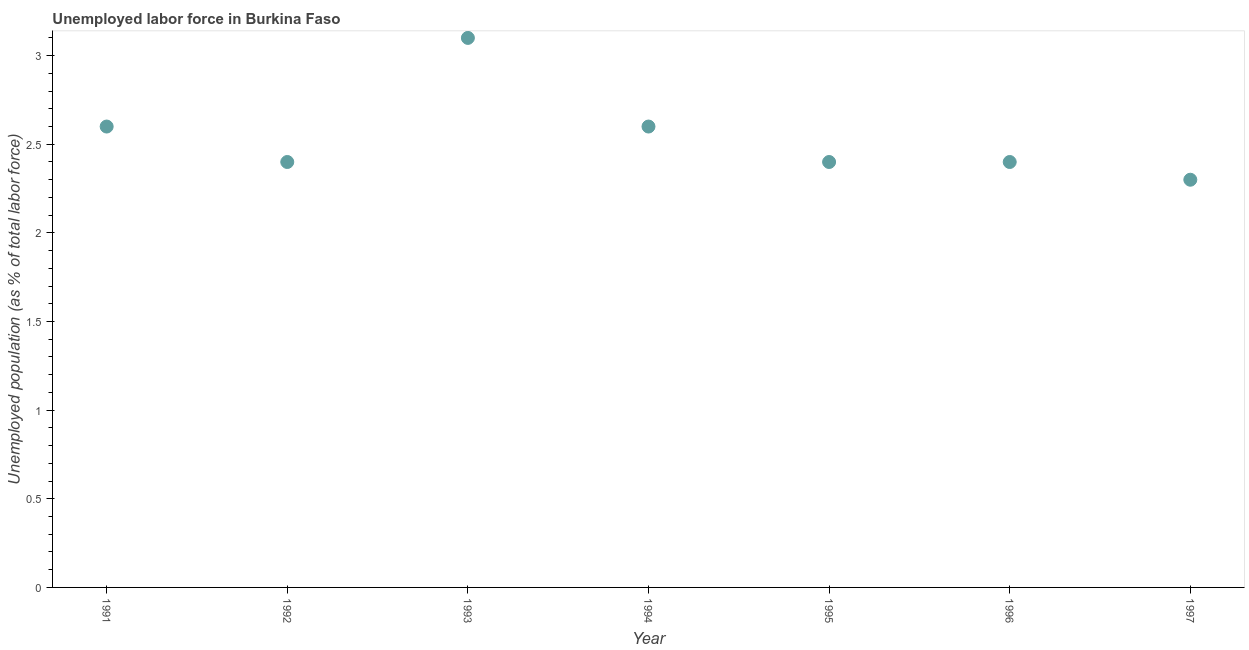What is the total unemployed population in 1991?
Give a very brief answer. 2.6. Across all years, what is the maximum total unemployed population?
Your response must be concise. 3.1. Across all years, what is the minimum total unemployed population?
Offer a terse response. 2.3. What is the sum of the total unemployed population?
Make the answer very short. 17.8. What is the difference between the total unemployed population in 1993 and 1997?
Provide a succinct answer. 0.8. What is the average total unemployed population per year?
Offer a very short reply. 2.54. What is the median total unemployed population?
Offer a very short reply. 2.4. In how many years, is the total unemployed population greater than 1.6 %?
Provide a succinct answer. 7. What is the ratio of the total unemployed population in 1993 to that in 1995?
Provide a short and direct response. 1.29. Is the total unemployed population in 1991 less than that in 1995?
Ensure brevity in your answer.  No. What is the difference between the highest and the second highest total unemployed population?
Give a very brief answer. 0.5. Is the sum of the total unemployed population in 1991 and 1994 greater than the maximum total unemployed population across all years?
Give a very brief answer. Yes. What is the difference between the highest and the lowest total unemployed population?
Your answer should be compact. 0.8. Does the total unemployed population monotonically increase over the years?
Make the answer very short. No. How many dotlines are there?
Provide a succinct answer. 1. Are the values on the major ticks of Y-axis written in scientific E-notation?
Provide a succinct answer. No. Does the graph contain grids?
Your answer should be very brief. No. What is the title of the graph?
Make the answer very short. Unemployed labor force in Burkina Faso. What is the label or title of the X-axis?
Offer a very short reply. Year. What is the label or title of the Y-axis?
Make the answer very short. Unemployed population (as % of total labor force). What is the Unemployed population (as % of total labor force) in 1991?
Keep it short and to the point. 2.6. What is the Unemployed population (as % of total labor force) in 1992?
Keep it short and to the point. 2.4. What is the Unemployed population (as % of total labor force) in 1993?
Ensure brevity in your answer.  3.1. What is the Unemployed population (as % of total labor force) in 1994?
Offer a terse response. 2.6. What is the Unemployed population (as % of total labor force) in 1995?
Your response must be concise. 2.4. What is the Unemployed population (as % of total labor force) in 1996?
Ensure brevity in your answer.  2.4. What is the Unemployed population (as % of total labor force) in 1997?
Your answer should be compact. 2.3. What is the difference between the Unemployed population (as % of total labor force) in 1991 and 1992?
Provide a succinct answer. 0.2. What is the difference between the Unemployed population (as % of total labor force) in 1991 and 1993?
Your answer should be very brief. -0.5. What is the difference between the Unemployed population (as % of total labor force) in 1991 and 1994?
Offer a terse response. 0. What is the difference between the Unemployed population (as % of total labor force) in 1991 and 1995?
Provide a succinct answer. 0.2. What is the difference between the Unemployed population (as % of total labor force) in 1991 and 1997?
Your answer should be compact. 0.3. What is the difference between the Unemployed population (as % of total labor force) in 1992 and 1994?
Make the answer very short. -0.2. What is the difference between the Unemployed population (as % of total labor force) in 1992 and 1996?
Give a very brief answer. 0. What is the difference between the Unemployed population (as % of total labor force) in 1992 and 1997?
Provide a short and direct response. 0.1. What is the difference between the Unemployed population (as % of total labor force) in 1994 and 1997?
Provide a short and direct response. 0.3. What is the difference between the Unemployed population (as % of total labor force) in 1996 and 1997?
Provide a short and direct response. 0.1. What is the ratio of the Unemployed population (as % of total labor force) in 1991 to that in 1992?
Your response must be concise. 1.08. What is the ratio of the Unemployed population (as % of total labor force) in 1991 to that in 1993?
Make the answer very short. 0.84. What is the ratio of the Unemployed population (as % of total labor force) in 1991 to that in 1995?
Ensure brevity in your answer.  1.08. What is the ratio of the Unemployed population (as % of total labor force) in 1991 to that in 1996?
Your response must be concise. 1.08. What is the ratio of the Unemployed population (as % of total labor force) in 1991 to that in 1997?
Your answer should be compact. 1.13. What is the ratio of the Unemployed population (as % of total labor force) in 1992 to that in 1993?
Offer a terse response. 0.77. What is the ratio of the Unemployed population (as % of total labor force) in 1992 to that in 1994?
Provide a succinct answer. 0.92. What is the ratio of the Unemployed population (as % of total labor force) in 1992 to that in 1997?
Make the answer very short. 1.04. What is the ratio of the Unemployed population (as % of total labor force) in 1993 to that in 1994?
Provide a succinct answer. 1.19. What is the ratio of the Unemployed population (as % of total labor force) in 1993 to that in 1995?
Your answer should be very brief. 1.29. What is the ratio of the Unemployed population (as % of total labor force) in 1993 to that in 1996?
Offer a terse response. 1.29. What is the ratio of the Unemployed population (as % of total labor force) in 1993 to that in 1997?
Offer a very short reply. 1.35. What is the ratio of the Unemployed population (as % of total labor force) in 1994 to that in 1995?
Offer a terse response. 1.08. What is the ratio of the Unemployed population (as % of total labor force) in 1994 to that in 1996?
Your answer should be very brief. 1.08. What is the ratio of the Unemployed population (as % of total labor force) in 1994 to that in 1997?
Offer a very short reply. 1.13. What is the ratio of the Unemployed population (as % of total labor force) in 1995 to that in 1997?
Provide a succinct answer. 1.04. What is the ratio of the Unemployed population (as % of total labor force) in 1996 to that in 1997?
Keep it short and to the point. 1.04. 